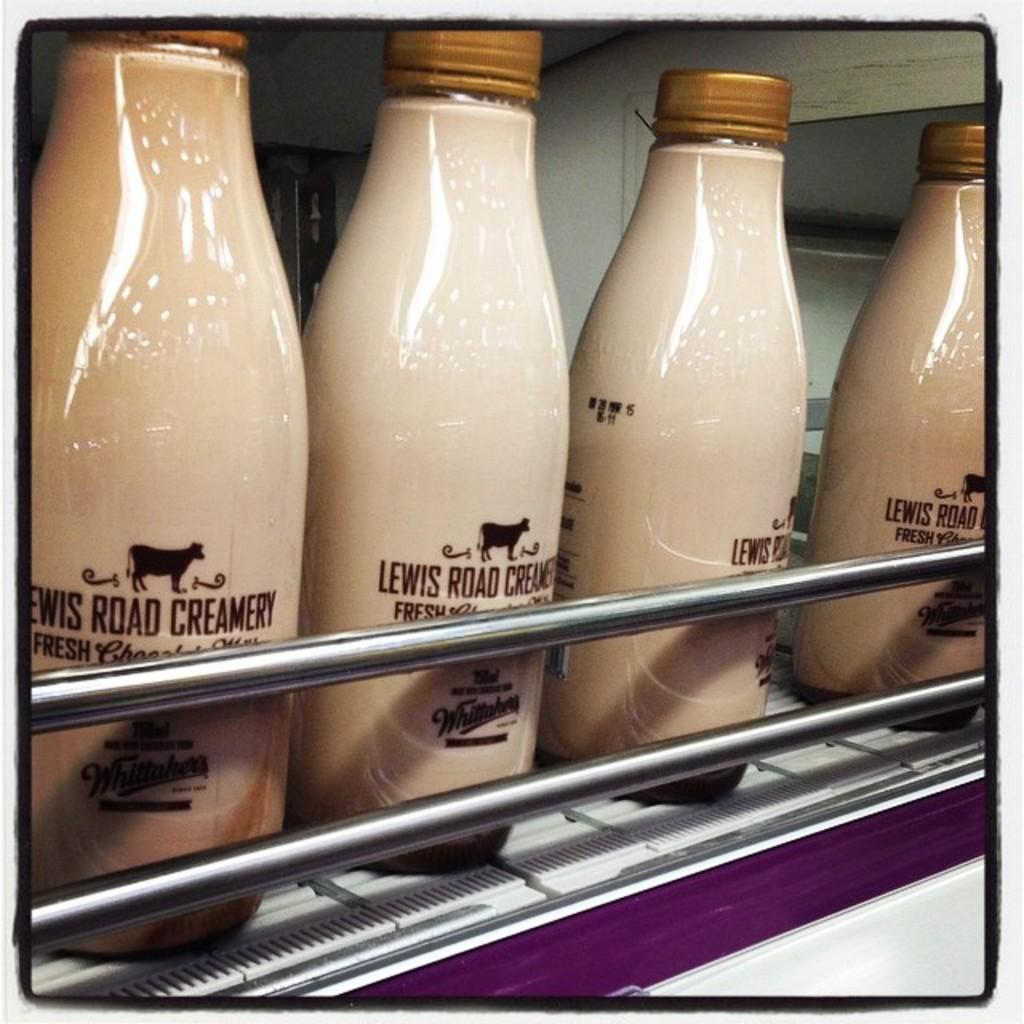What objects are present in the image that resemble containers? There are bottles in the image. What can be seen on the bottles? The bottles have text on them. What type of objects are in the foreground of the image? There are metal rods in the foreground of the image. What type of paste can be seen being applied to the bottles in the image? There is no paste present in the image, nor is any paste being applied to the bottles. What type of voice can be heard coming from the bottles in the image? There is no voice present in the image, as bottles are inanimate objects and cannot produce sound. 